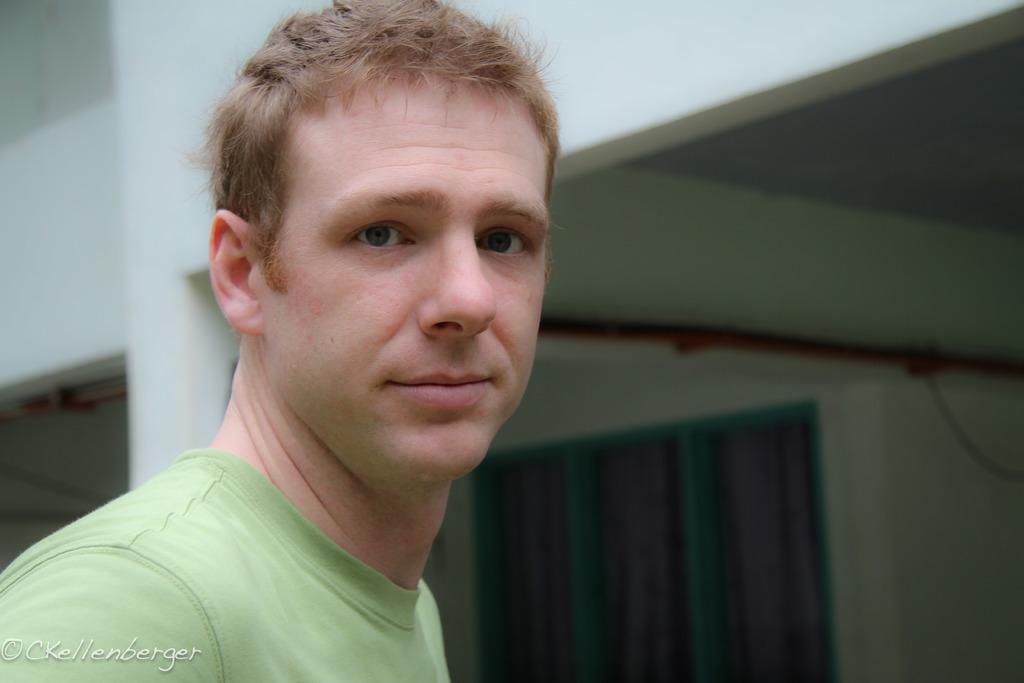Who is present in the image? There is a man in the image. What can be seen in the background of the image? There is a building and a window in the background of the image. What is on the wall in the background of the image? There is an object on the wall in the background of the image. What type of income can be seen in the image? There is no reference to income in the image, so it cannot be determined from the image. 